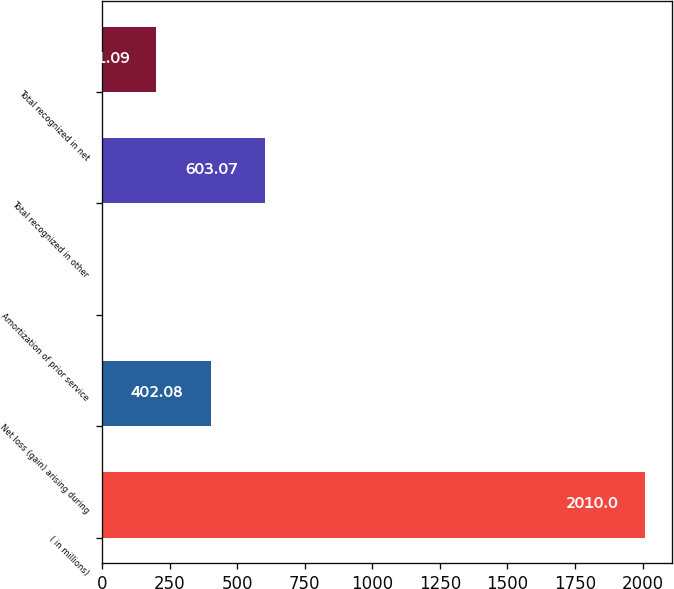<chart> <loc_0><loc_0><loc_500><loc_500><bar_chart><fcel>( in millions)<fcel>Net loss (gain) arising during<fcel>Amortization of prior service<fcel>Total recognized in other<fcel>Total recognized in net<nl><fcel>2010<fcel>402.08<fcel>0.1<fcel>603.07<fcel>201.09<nl></chart> 